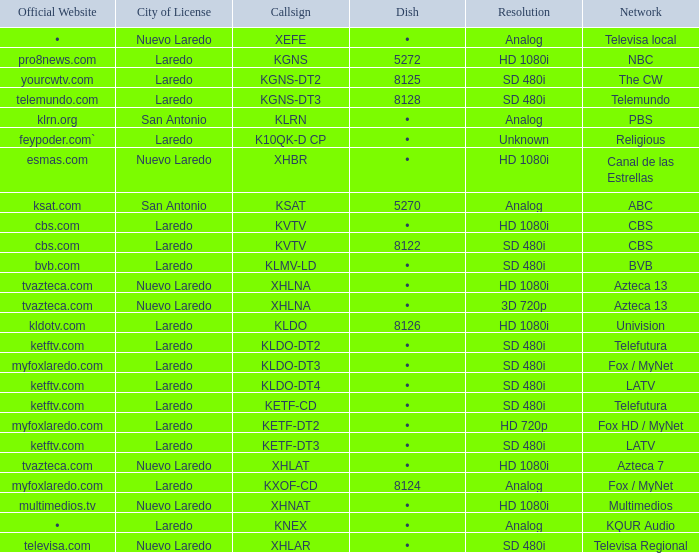Name the dish for resolution of sd 480i and network of bvb •. 